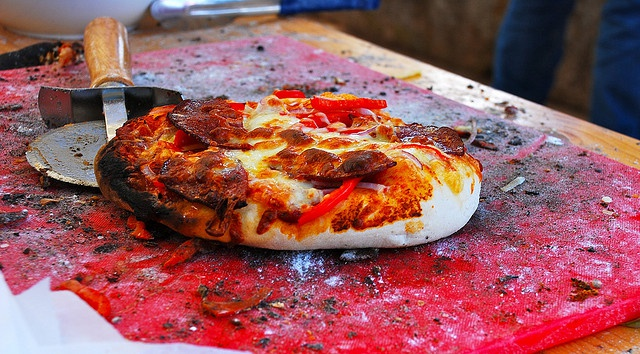Describe the objects in this image and their specific colors. I can see dining table in gray, brown, maroon, black, and darkgray tones, pizza in gray, maroon, brown, black, and red tones, people in gray, black, navy, and lavender tones, bowl in gray tones, and knife in gray, darkgray, and lightgray tones in this image. 